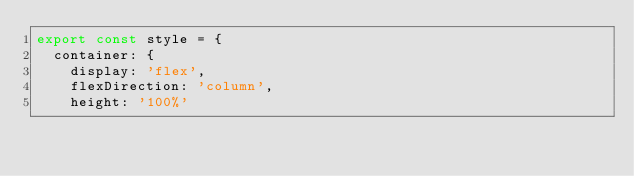<code> <loc_0><loc_0><loc_500><loc_500><_JavaScript_>export const style = {
  container: {
    display: 'flex',
    flexDirection: 'column',
    height: '100%'</code> 